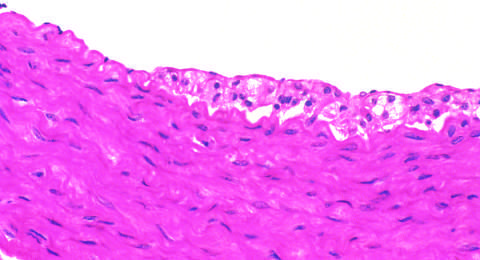does the fatty streak in an experimental hypercholesterolemic rabbit demonstrate intimal, macrophage-derived foam cells?
Answer the question using a single word or phrase. Yes 